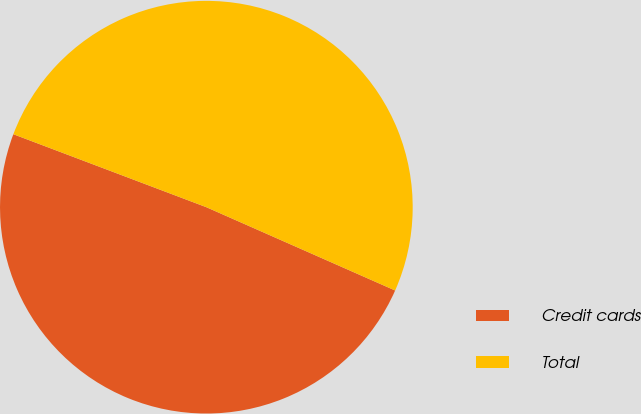Convert chart to OTSL. <chart><loc_0><loc_0><loc_500><loc_500><pie_chart><fcel>Credit cards<fcel>Total<nl><fcel>49.14%<fcel>50.86%<nl></chart> 